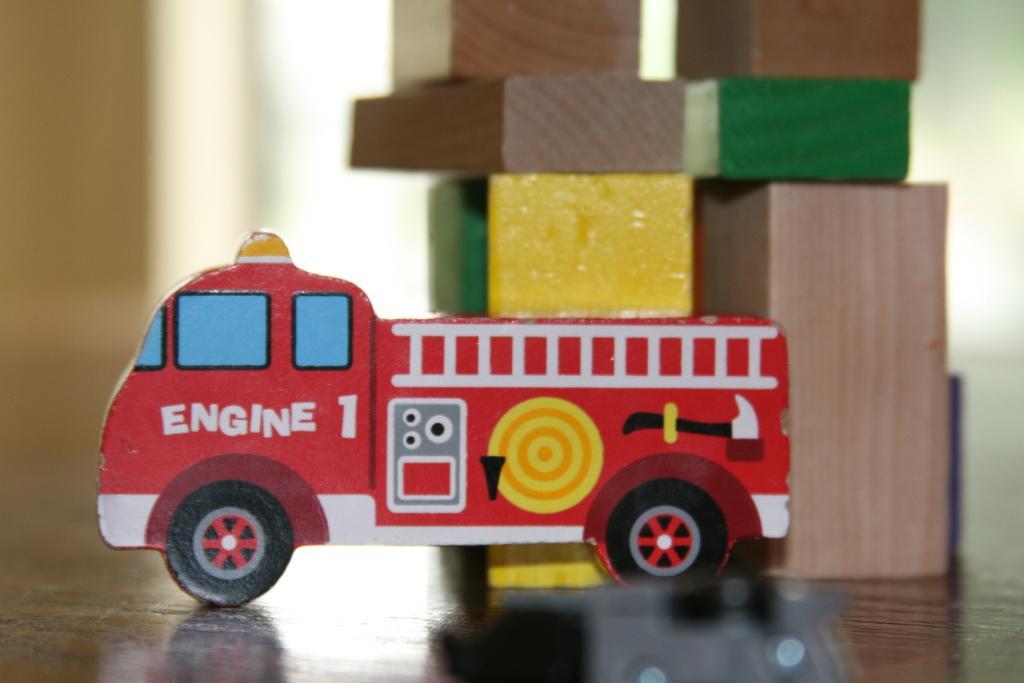How would you summarize this image in a sentence or two? In this image I can see a toy vehicle which is red, white, yellow and black in color. I can see few wooden blocks and the blurry background. 